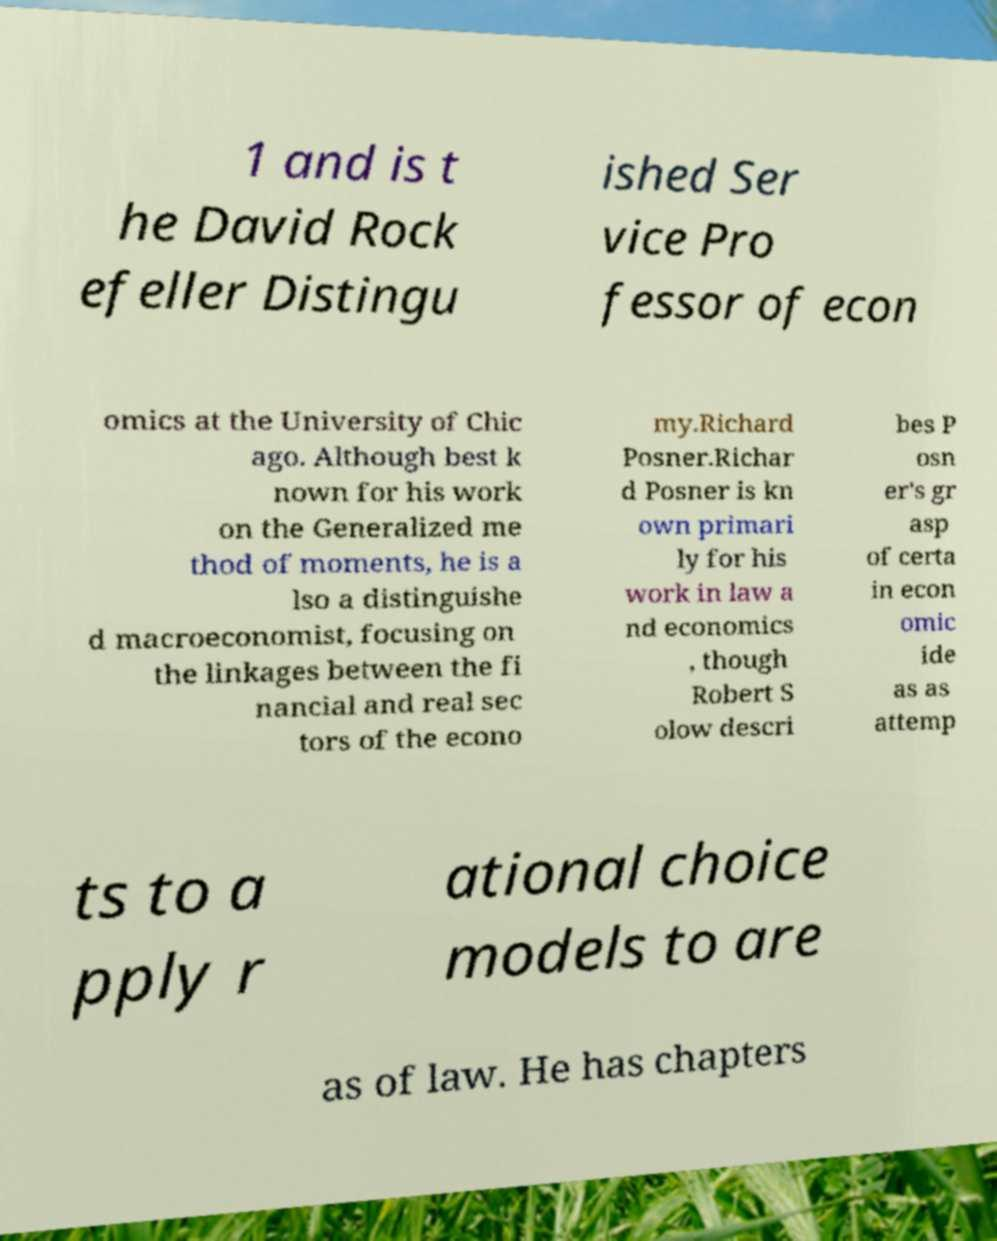Could you assist in decoding the text presented in this image and type it out clearly? 1 and is t he David Rock efeller Distingu ished Ser vice Pro fessor of econ omics at the University of Chic ago. Although best k nown for his work on the Generalized me thod of moments, he is a lso a distinguishe d macroeconomist, focusing on the linkages between the fi nancial and real sec tors of the econo my.Richard Posner.Richar d Posner is kn own primari ly for his work in law a nd economics , though Robert S olow descri bes P osn er's gr asp of certa in econ omic ide as as attemp ts to a pply r ational choice models to are as of law. He has chapters 